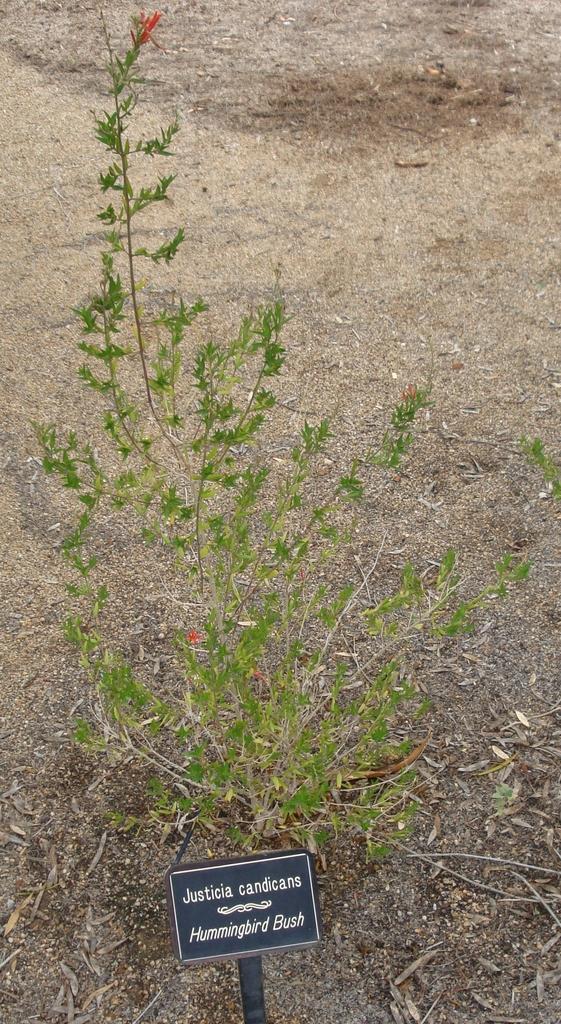How would you summarize this image in a sentence or two? In this image I can see a black colour board in the front and on it I can see something is written. I can also see a planet behind the board. 